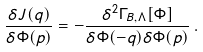Convert formula to latex. <formula><loc_0><loc_0><loc_500><loc_500>\frac { \delta J ( q ) } { \delta \Phi ( p ) } = - \frac { \delta ^ { 2 } \Gamma _ { B , \Lambda } [ \Phi ] } { \delta \Phi ( - q ) \delta \Phi ( p ) } \, .</formula> 